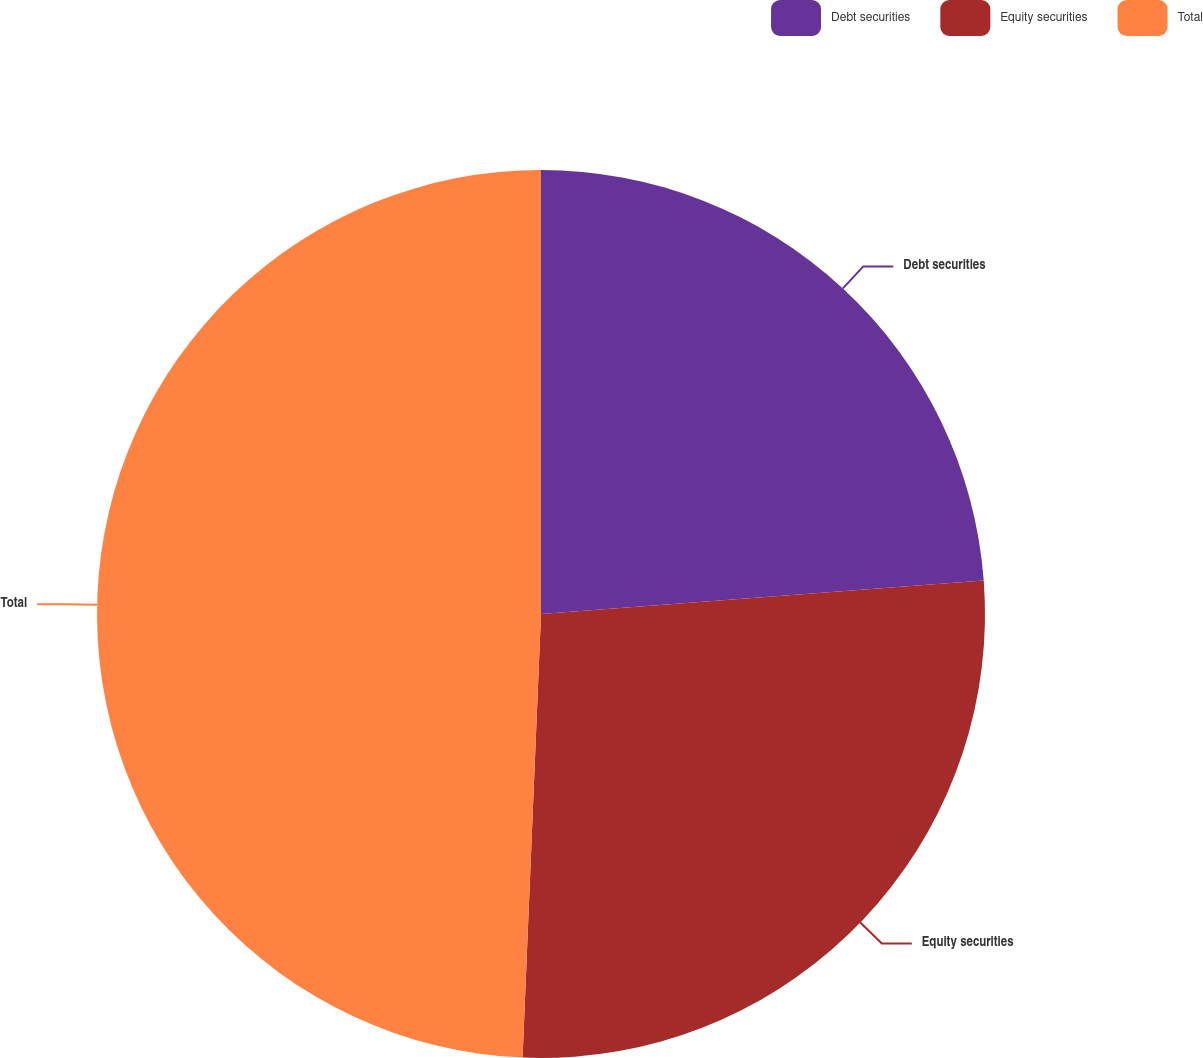Convert chart. <chart><loc_0><loc_0><loc_500><loc_500><pie_chart><fcel>Debt securities<fcel>Equity securities<fcel>Total<nl><fcel>23.8%<fcel>26.86%<fcel>49.34%<nl></chart> 